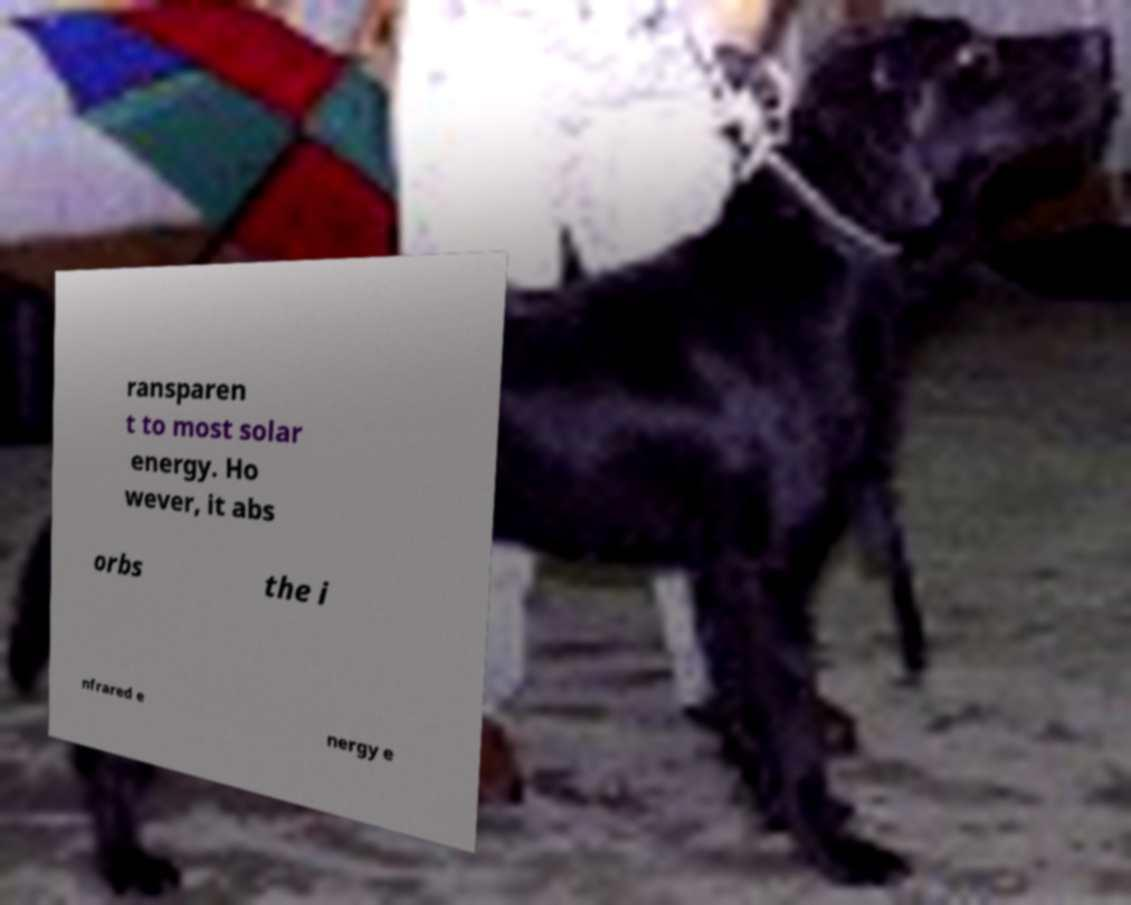Can you accurately transcribe the text from the provided image for me? ransparen t to most solar energy. Ho wever, it abs orbs the i nfrared e nergy e 